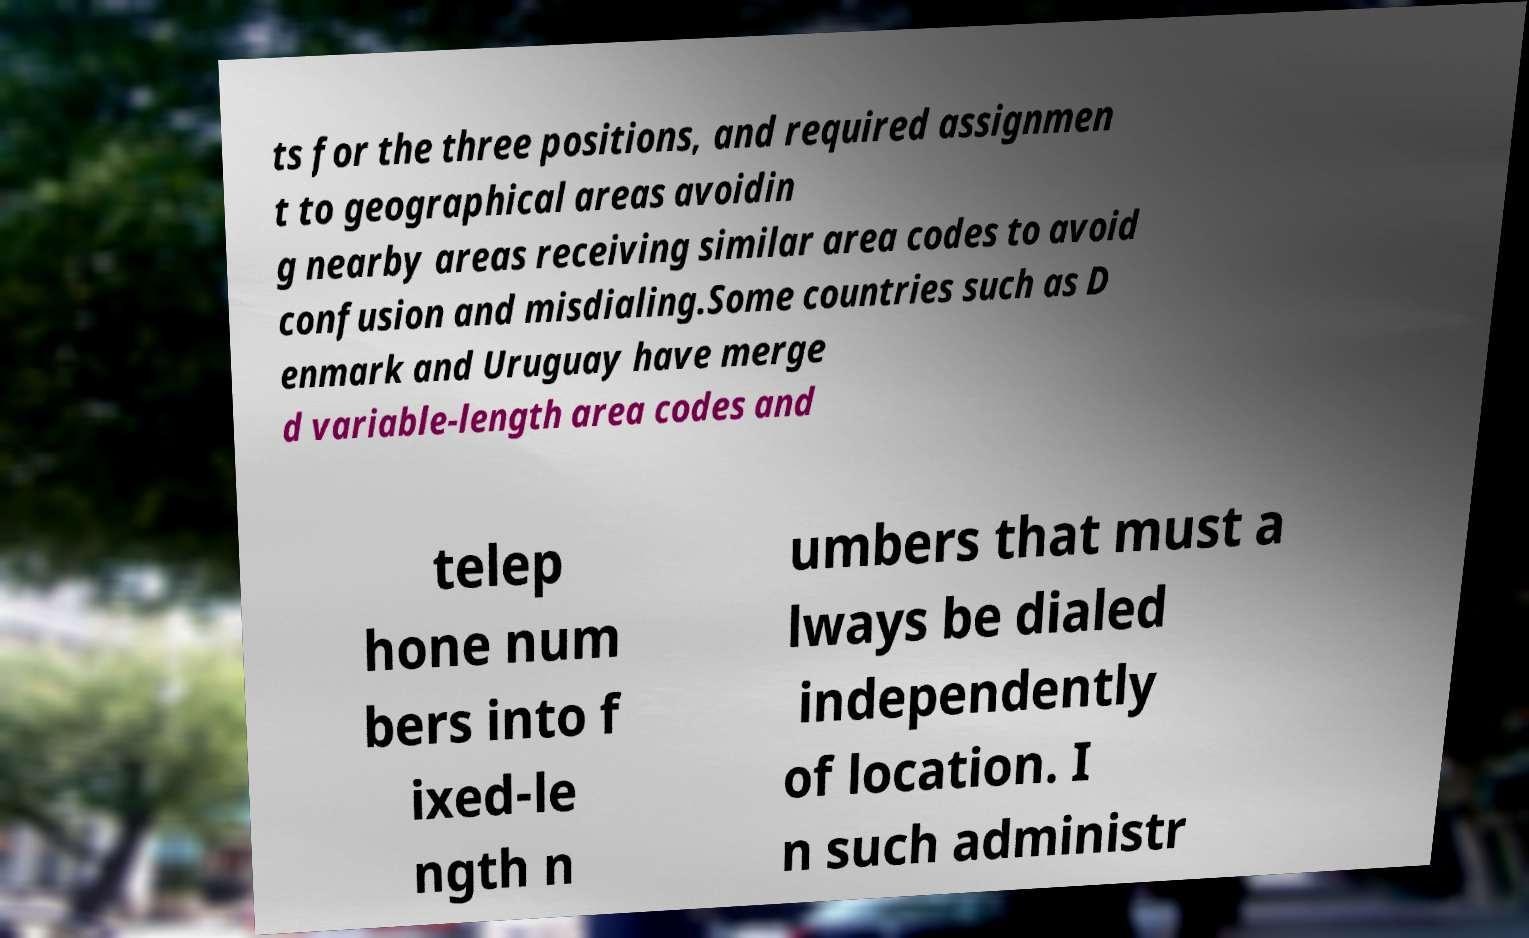Please identify and transcribe the text found in this image. ts for the three positions, and required assignmen t to geographical areas avoidin g nearby areas receiving similar area codes to avoid confusion and misdialing.Some countries such as D enmark and Uruguay have merge d variable-length area codes and telep hone num bers into f ixed-le ngth n umbers that must a lways be dialed independently of location. I n such administr 